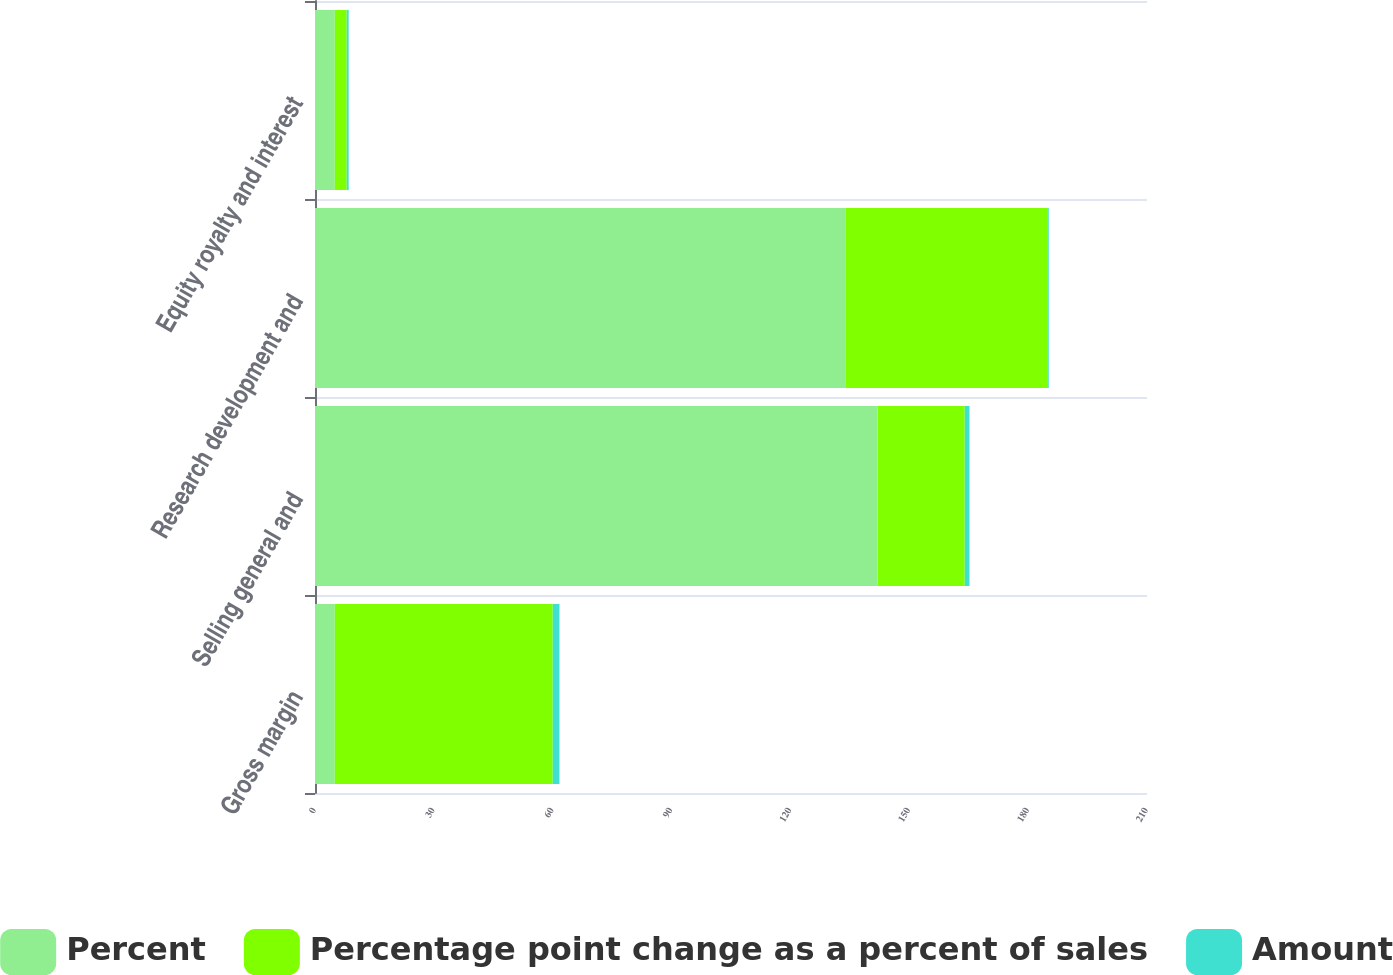<chart> <loc_0><loc_0><loc_500><loc_500><stacked_bar_chart><ecel><fcel>Gross margin<fcel>Selling general and<fcel>Research development and<fcel>Equity royalty and interest<nl><fcel>Percent<fcel>5<fcel>142<fcel>134<fcel>5<nl><fcel>Percentage point change as a percent of sales<fcel>55<fcel>22<fcel>51<fcel>3<nl><fcel>Amount<fcel>1.7<fcel>1.2<fcel>0.2<fcel>0.5<nl></chart> 